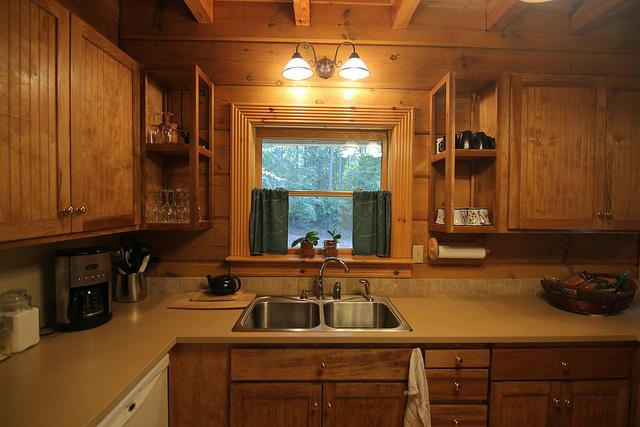What kind of sink is this?

Choices:
A) kitchen
B) bathroom
C) laundry
D) workstation kitchen 